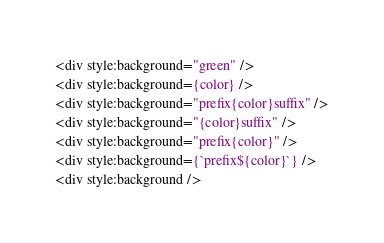<code> <loc_0><loc_0><loc_500><loc_500><_HTML_><div style:background="green" />
<div style:background={color} />
<div style:background="prefix{color}suffix" />
<div style:background="{color}suffix" />
<div style:background="prefix{color}" />
<div style:background={`prefix${color}`} />
<div style:background />
</code> 